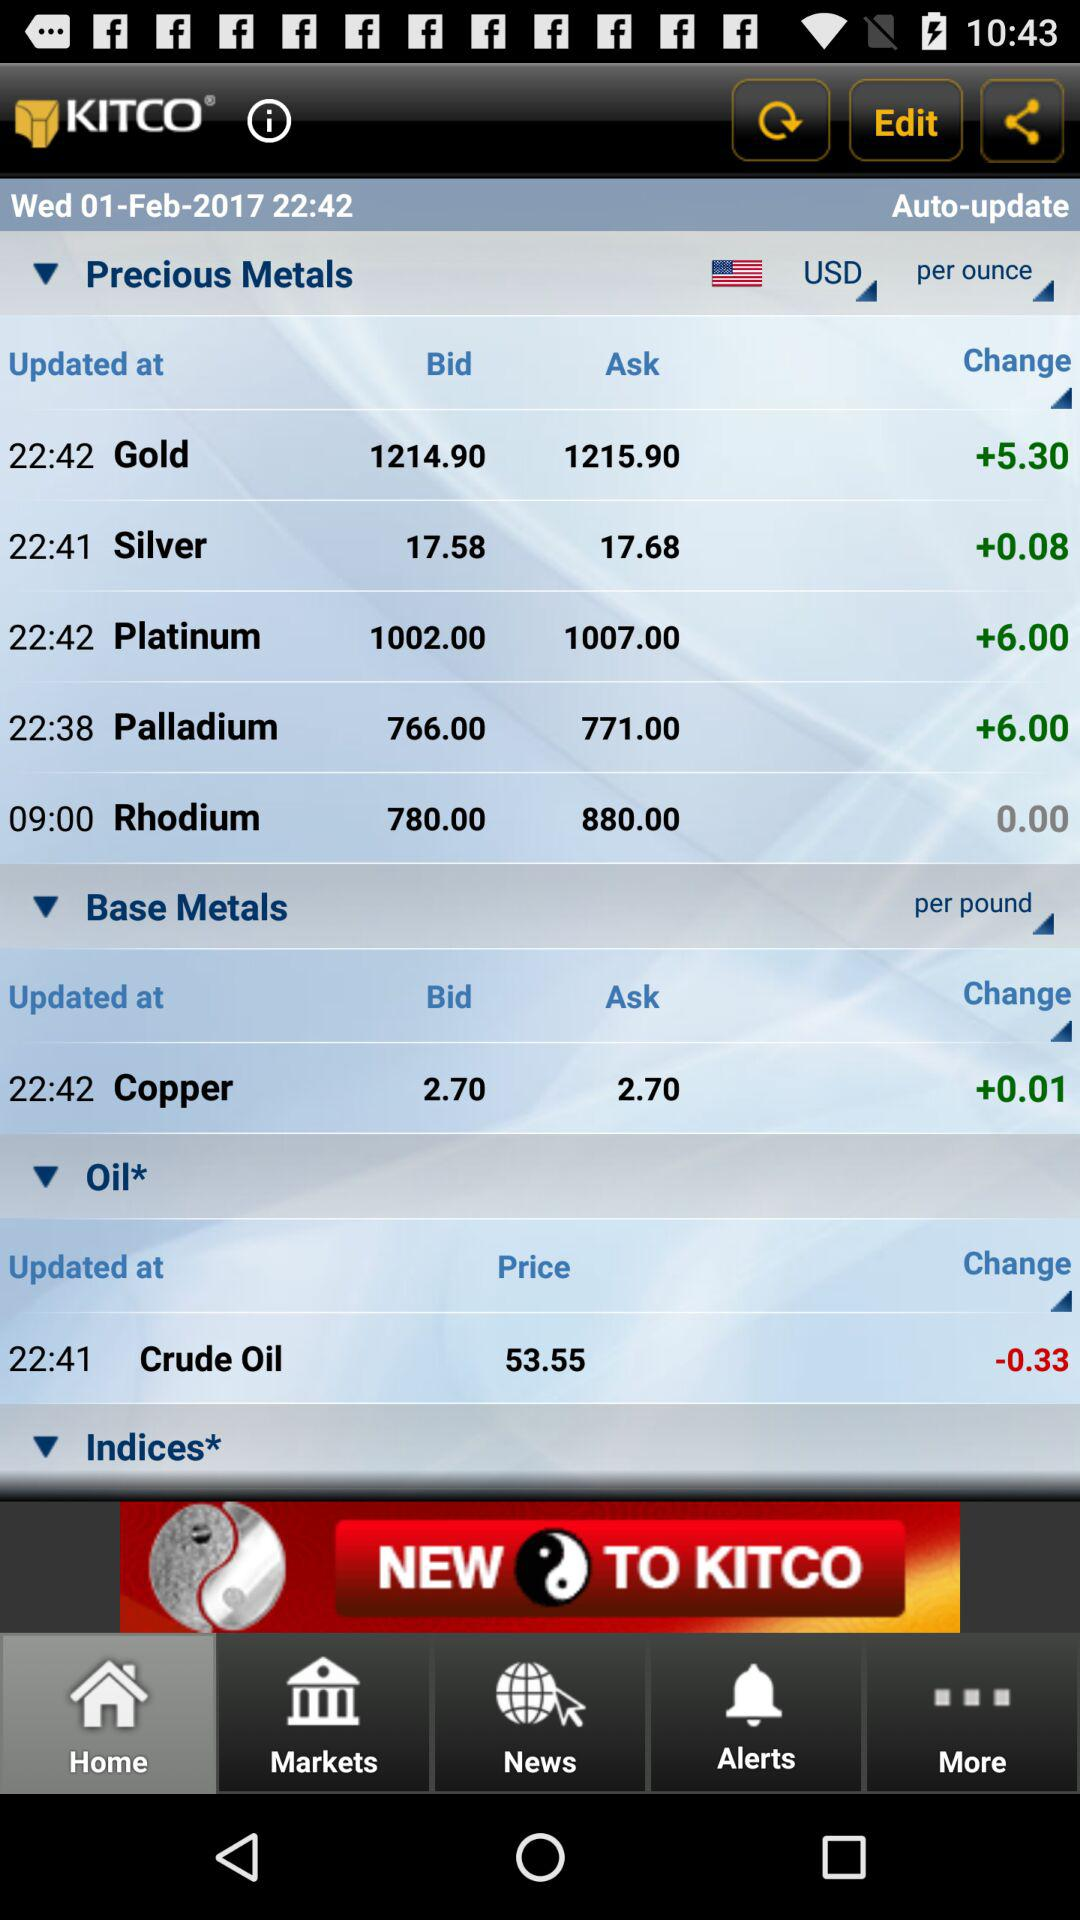When was the "Platinum" metal updated? The "Platinum" metal was updated at 22:42. 